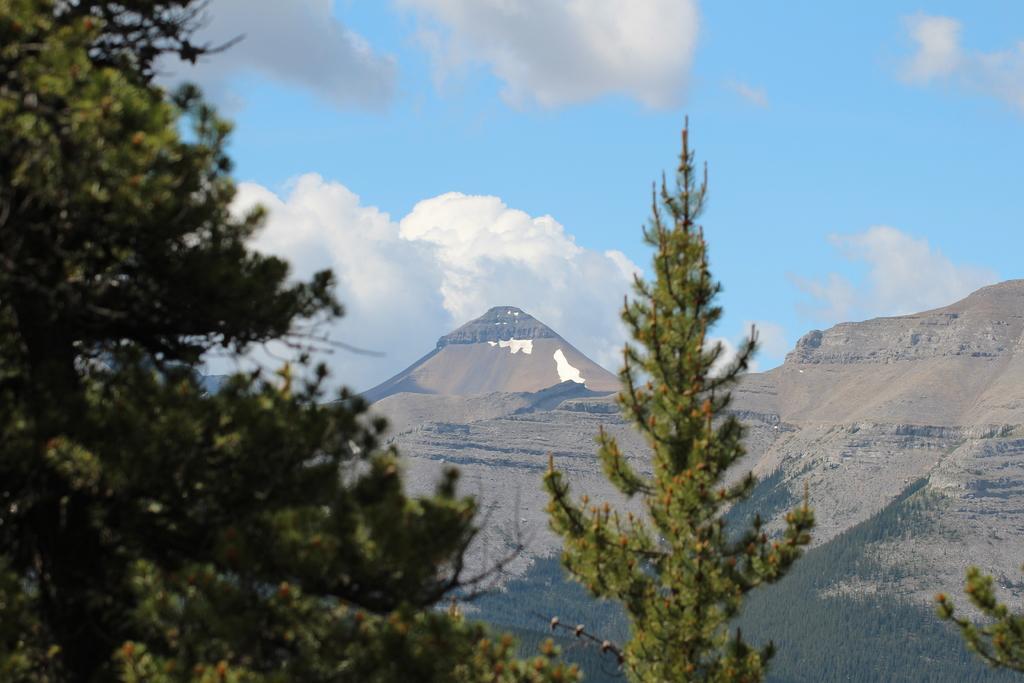Can you describe this image briefly? In this image there are trees, mountains and cloudy sky. 